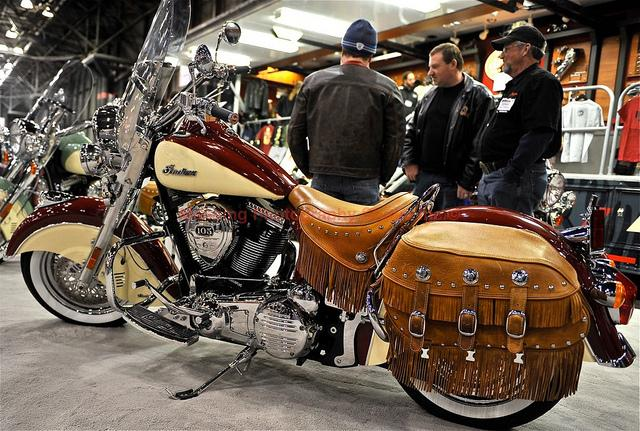What style is this bike decorated in? Please explain your reasoning. cowboy. The motorcycle has leather decorations and fringe that might be see worn by a cowboy. 